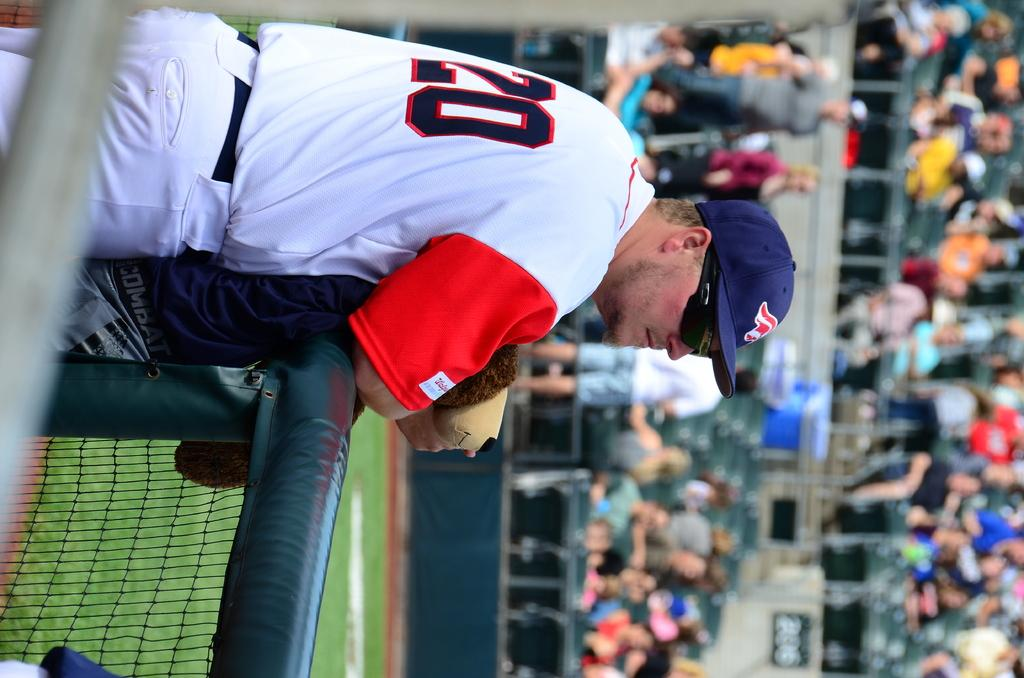<image>
Describe the image concisely. Player 20 standing next to the fence watching the game 